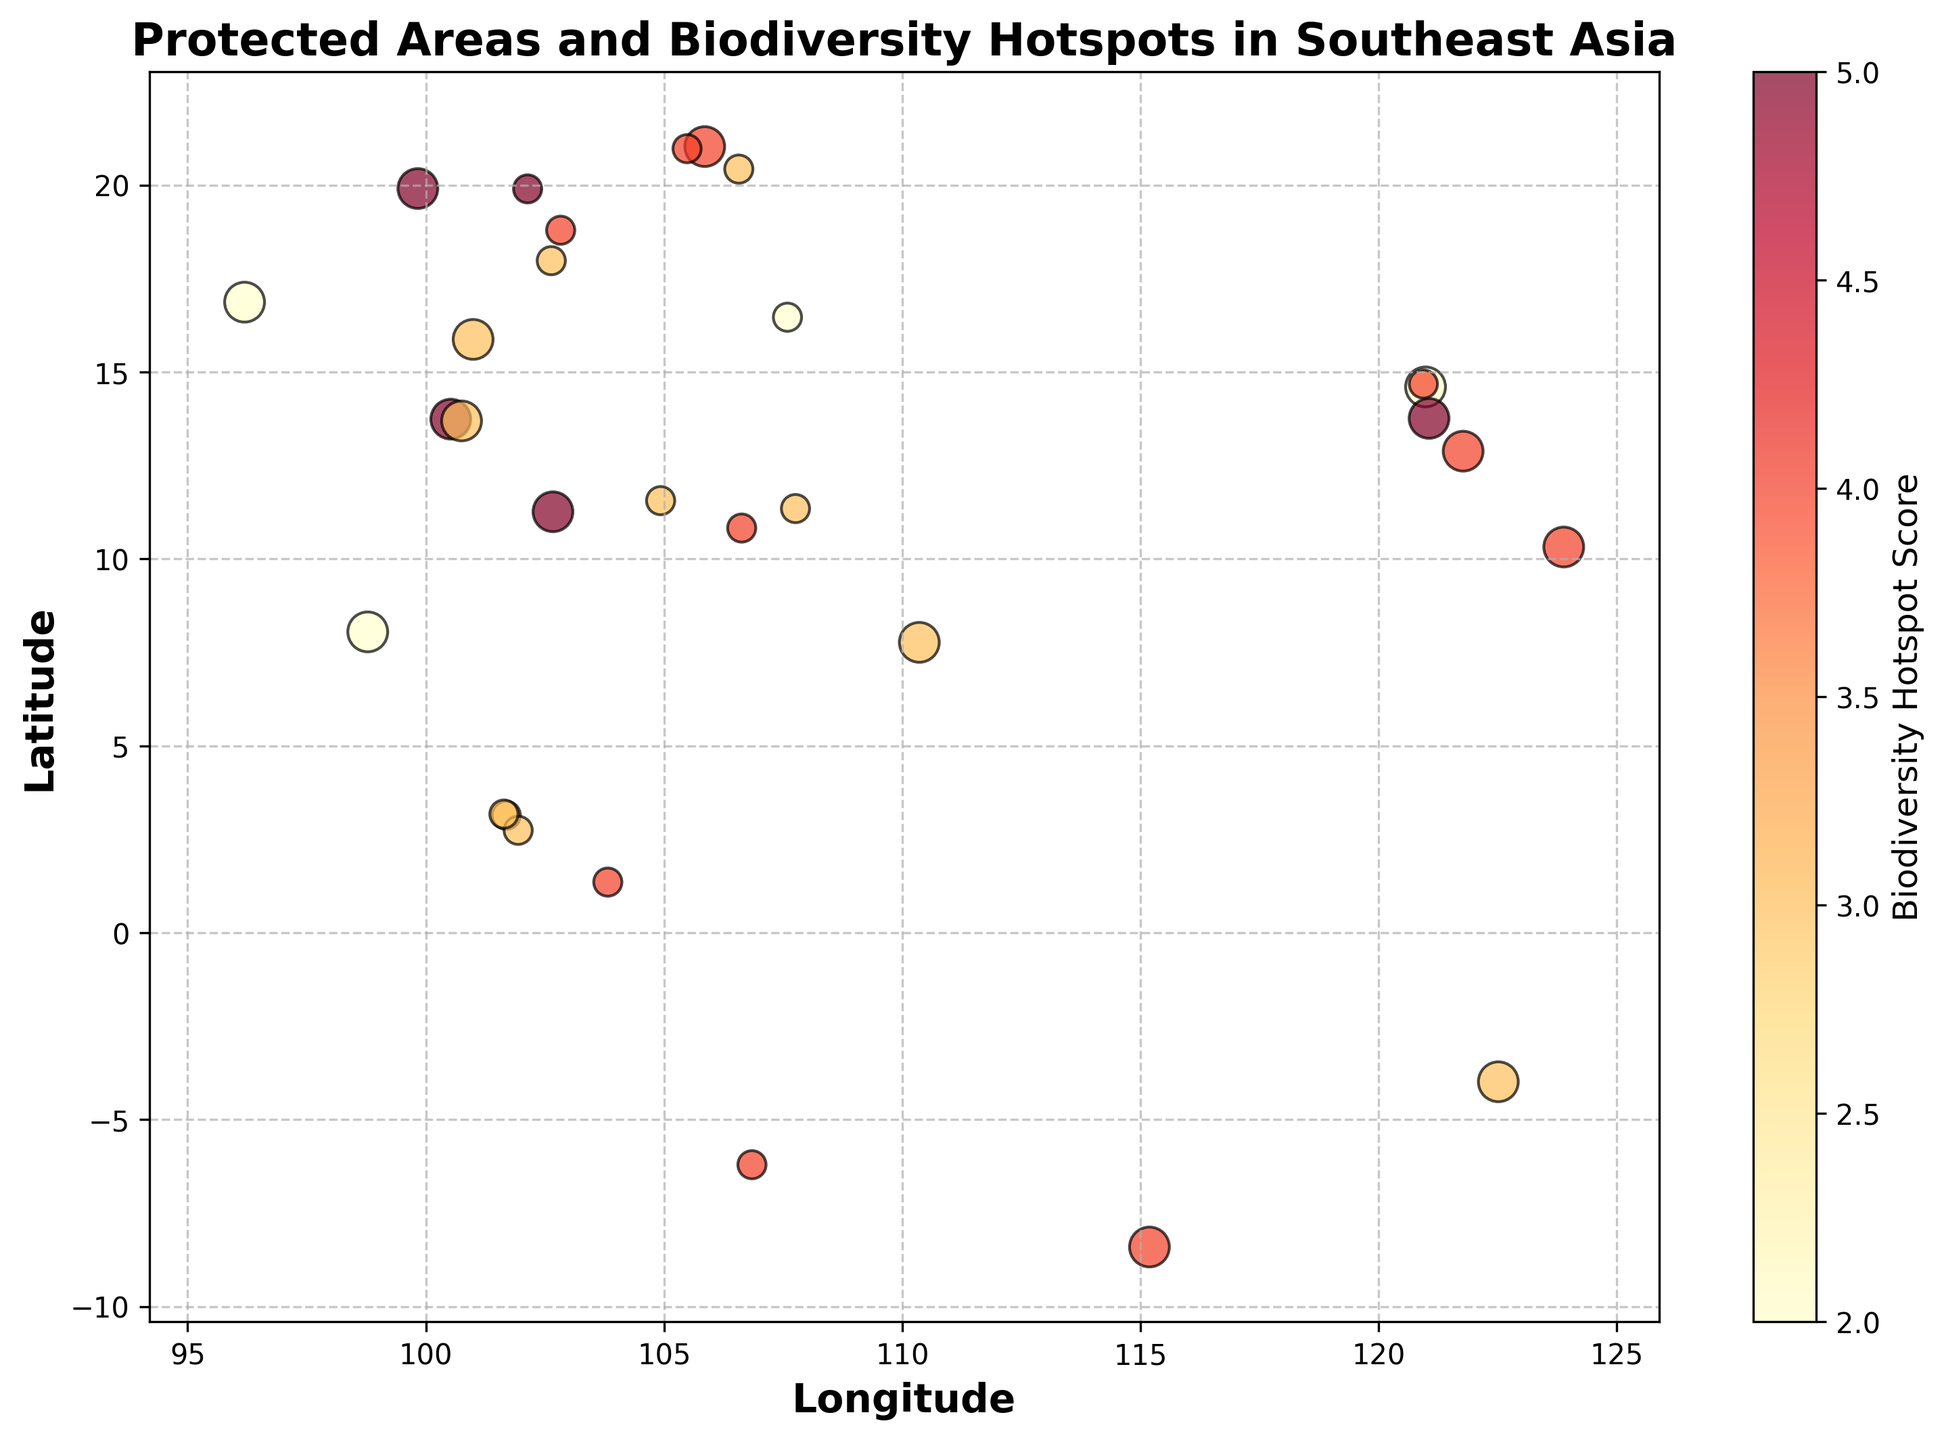Which city has the highest biodiversity hotspot score? Look for the yellowish-red points on the scatter plot and locate the corresponding city on the y-axis. The one with the largest yellowish-red point has the highest score.
Answer: Bangkok (13.7367,100.5231) Which cities show both high protected area size and high hotspot scores? Identify the size of the circles and their color. Large circles with darker red denote both high protected area size and high hotspot scores.
Answer: Cebu (10.3157,123.8854), Ho Chi Minh City (10.8231,106.6297) Which city has the smallest protected area with the highest biodiversity hotspot score? Find the smallest circles on the plot and check their colors. Locate the city with the smallest circle that is dark red.
Answer: Luang Prabang (19.8968,102.1364) Compare Bangkok and Kuala Lumpur: Which one has a higher protected area and biodiversity hotspot score? Find their positions on the scatter plot and compare the size and color of the circles. Larger and more reddish circles denote higher values.
Answer: Bangkok (both higher in protected area and hotspot score) What is the average biodiversity hotspot score for the cities in Indonesia? Identify all cities in Indonesia. Sum up their hotspot scores and divide by the number of cities.
Answer: 3.75 (Jakarta: 4, Surabaya: 3, Yogyakarta: 3, Mataram: 4) Which Vietnamese city has the highest biodiversity hotspot score? Look for cities in Vietnam on the plot and compare their hotspot scores. The city with the most reddish circle has the highest score.
Answer: Hanoi (21.0285,105.8542) How many cities have a protected area size of 1 and a hotspot score of 4? Find all cities with circles of size 1 that are red or dark red.
Answer: 4 (Singapore, Jakarta, Ho Chi Minh City, Hanoi) Between Philippines and Malaysia, which country has a city with the top hotspot score? Compare the hotspot scores of cities in both countries. Look for the highest score between them.
Answer: Malaysia (Luang Prabang: 5) What's the median biodiversity hotspot score for Thailand's cities? List all Thai cities, sort their hotspot scores, find the middle value.
Answer: 4 (Scores: 2, 3, 4, 5, 5) 